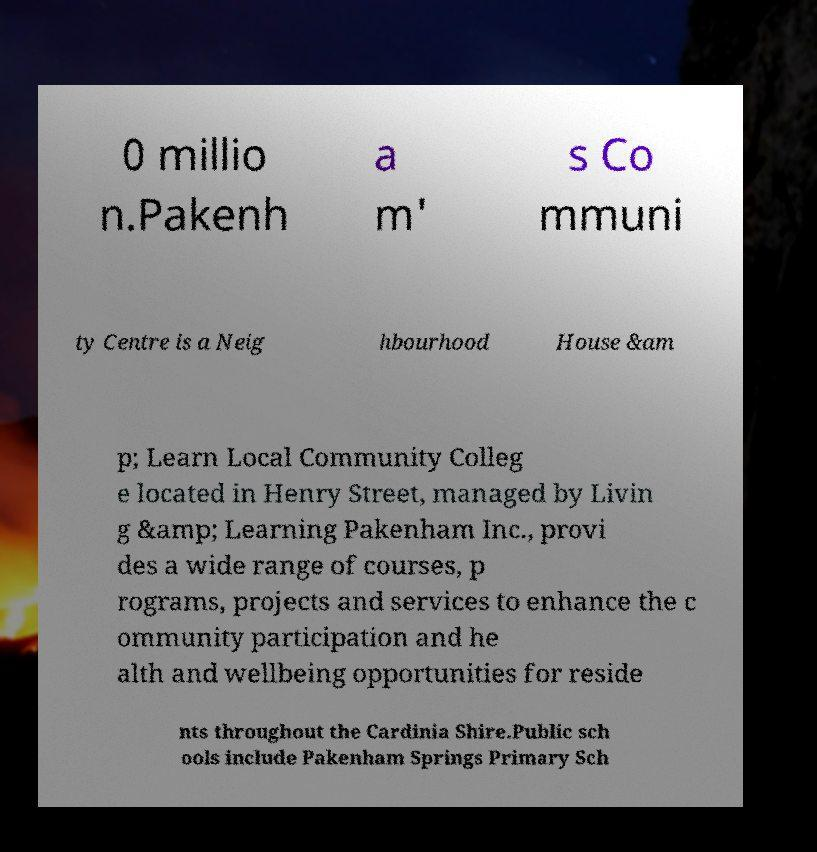Can you read and provide the text displayed in the image?This photo seems to have some interesting text. Can you extract and type it out for me? 0 millio n.Pakenh a m' s Co mmuni ty Centre is a Neig hbourhood House &am p; Learn Local Community Colleg e located in Henry Street, managed by Livin g &amp; Learning Pakenham Inc., provi des a wide range of courses, p rograms, projects and services to enhance the c ommunity participation and he alth and wellbeing opportunities for reside nts throughout the Cardinia Shire.Public sch ools include Pakenham Springs Primary Sch 